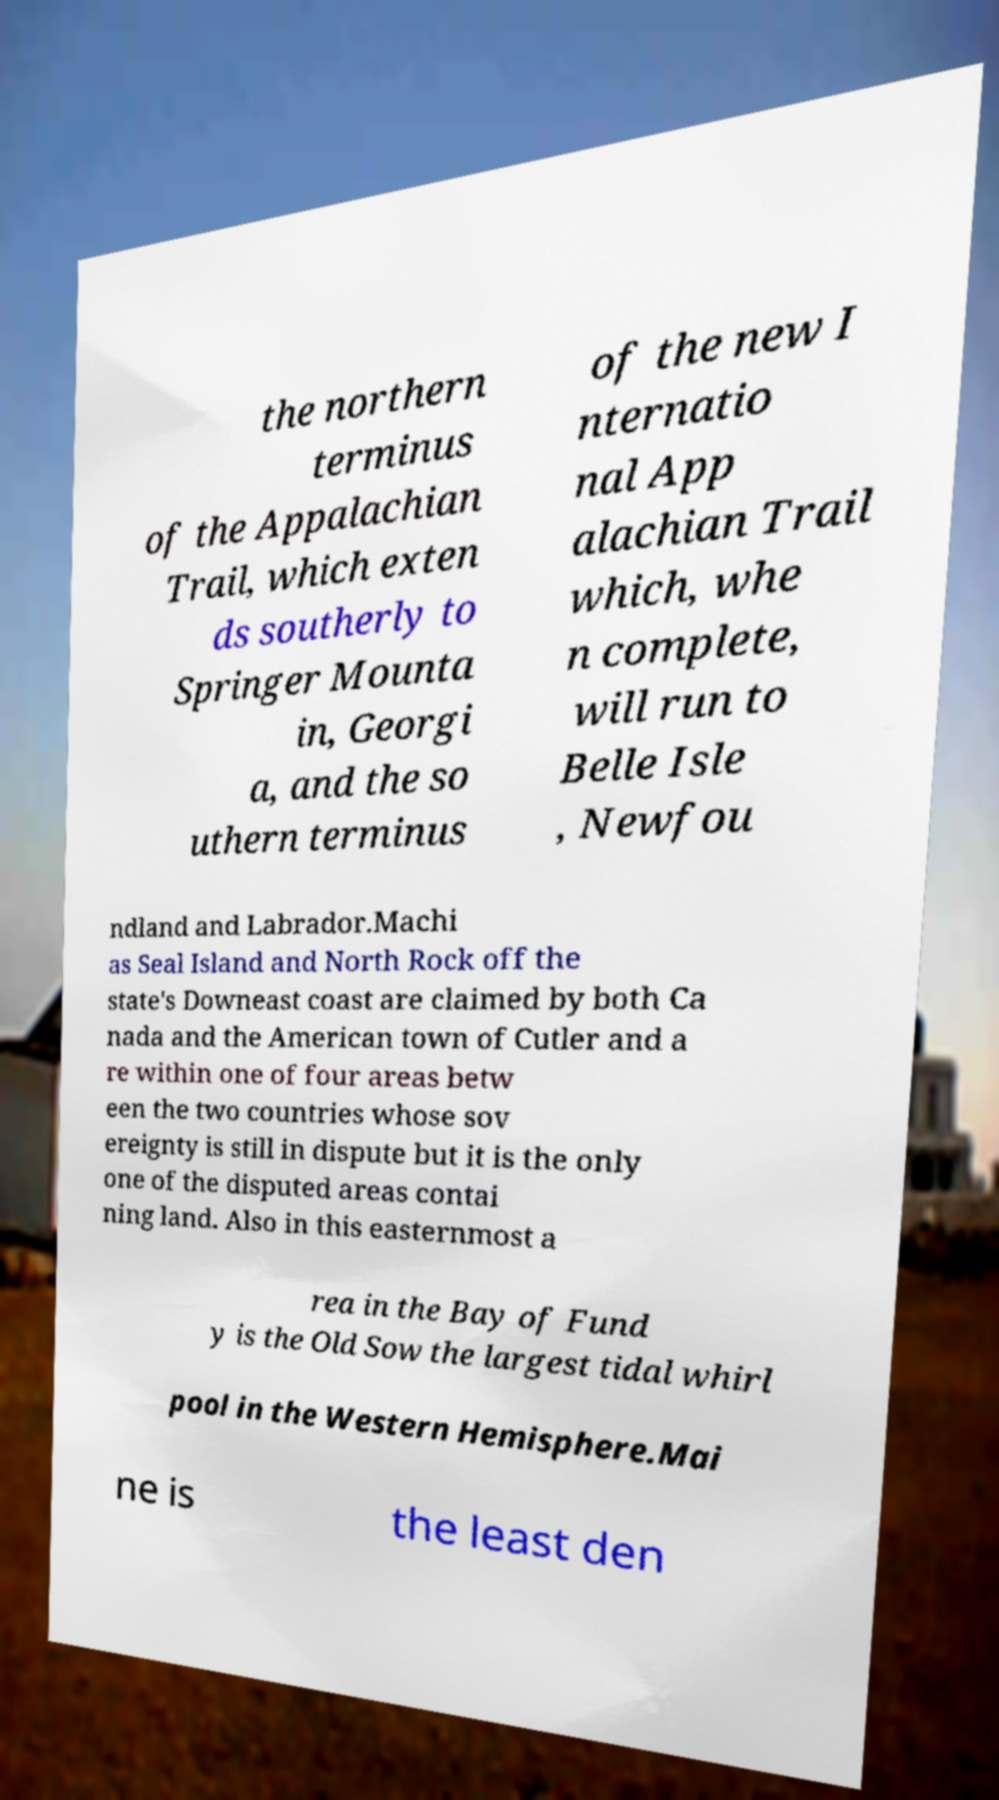What messages or text are displayed in this image? I need them in a readable, typed format. the northern terminus of the Appalachian Trail, which exten ds southerly to Springer Mounta in, Georgi a, and the so uthern terminus of the new I nternatio nal App alachian Trail which, whe n complete, will run to Belle Isle , Newfou ndland and Labrador.Machi as Seal Island and North Rock off the state's Downeast coast are claimed by both Ca nada and the American town of Cutler and a re within one of four areas betw een the two countries whose sov ereignty is still in dispute but it is the only one of the disputed areas contai ning land. Also in this easternmost a rea in the Bay of Fund y is the Old Sow the largest tidal whirl pool in the Western Hemisphere.Mai ne is the least den 